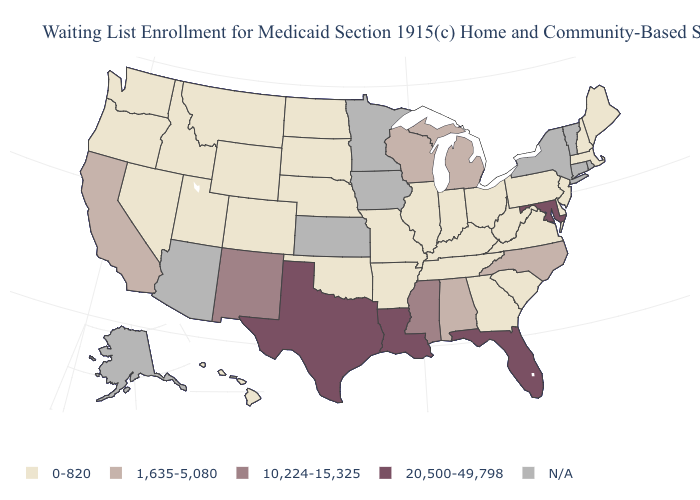Name the states that have a value in the range 1,635-5,080?
Keep it brief. Alabama, California, Michigan, North Carolina, Wisconsin. Name the states that have a value in the range 20,500-49,798?
Short answer required. Florida, Louisiana, Maryland, Texas. Name the states that have a value in the range 1,635-5,080?
Concise answer only. Alabama, California, Michigan, North Carolina, Wisconsin. Which states have the highest value in the USA?
Answer briefly. Florida, Louisiana, Maryland, Texas. How many symbols are there in the legend?
Concise answer only. 5. Which states have the lowest value in the South?
Be succinct. Arkansas, Delaware, Georgia, Kentucky, Oklahoma, South Carolina, Tennessee, Virginia, West Virginia. What is the highest value in states that border Kentucky?
Short answer required. 0-820. What is the value of Kentucky?
Give a very brief answer. 0-820. What is the lowest value in the MidWest?
Write a very short answer. 0-820. Which states have the lowest value in the USA?
Answer briefly. Arkansas, Colorado, Delaware, Georgia, Hawaii, Idaho, Illinois, Indiana, Kentucky, Maine, Massachusetts, Missouri, Montana, Nebraska, Nevada, New Hampshire, New Jersey, North Dakota, Ohio, Oklahoma, Oregon, Pennsylvania, South Carolina, South Dakota, Tennessee, Utah, Virginia, Washington, West Virginia, Wyoming. What is the value of Michigan?
Quick response, please. 1,635-5,080. Does Pennsylvania have the lowest value in the USA?
Be succinct. Yes. What is the value of California?
Be succinct. 1,635-5,080. Is the legend a continuous bar?
Give a very brief answer. No. 